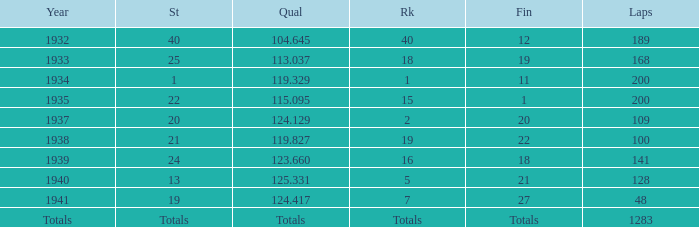What was the finish place with a qual of 123.660? 18.0. 